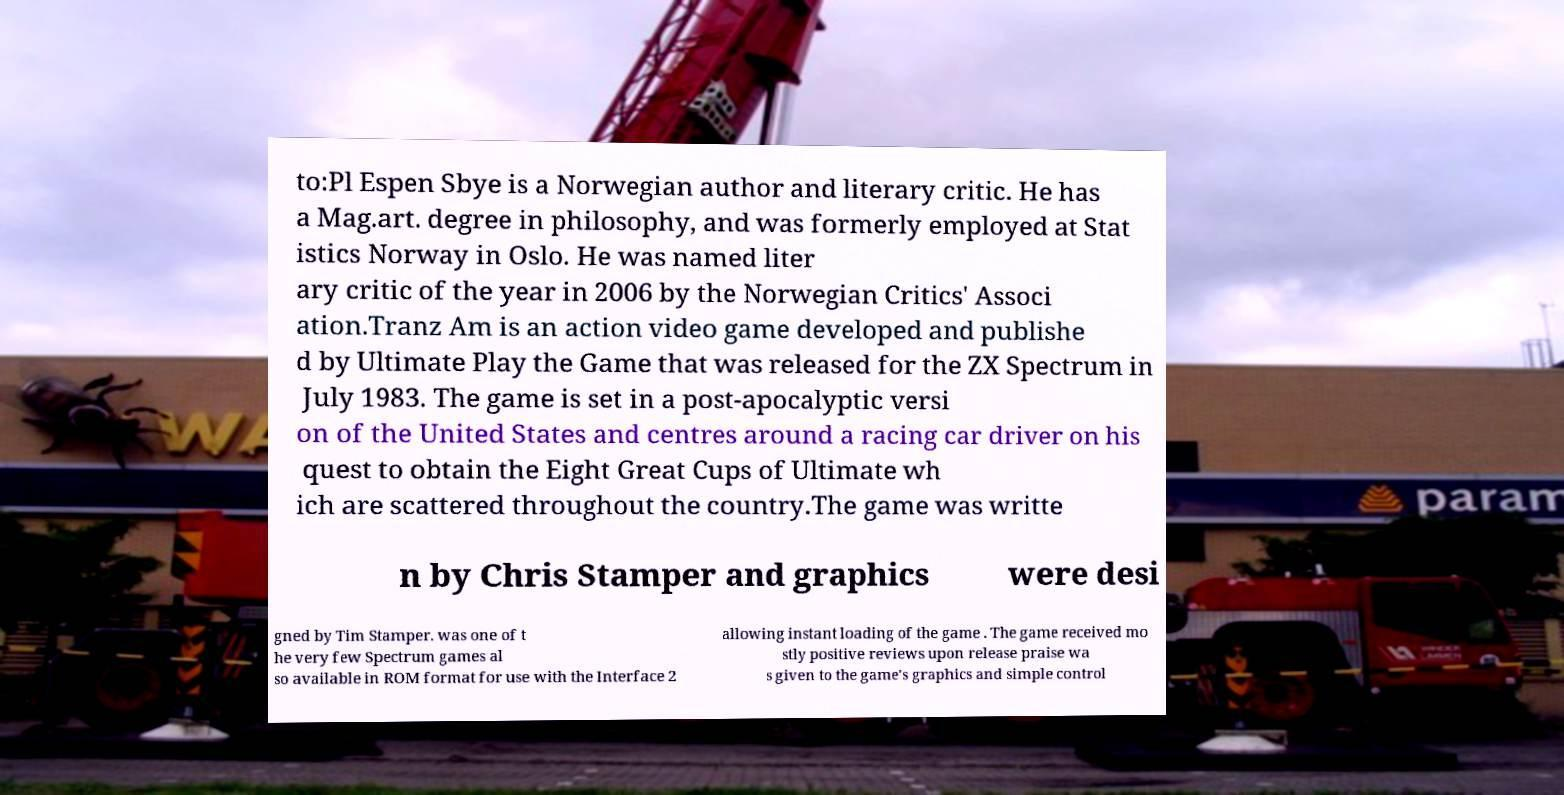Could you extract and type out the text from this image? to:Pl Espen Sbye is a Norwegian author and literary critic. He has a Mag.art. degree in philosophy, and was formerly employed at Stat istics Norway in Oslo. He was named liter ary critic of the year in 2006 by the Norwegian Critics' Associ ation.Tranz Am is an action video game developed and publishe d by Ultimate Play the Game that was released for the ZX Spectrum in July 1983. The game is set in a post-apocalyptic versi on of the United States and centres around a racing car driver on his quest to obtain the Eight Great Cups of Ultimate wh ich are scattered throughout the country.The game was writte n by Chris Stamper and graphics were desi gned by Tim Stamper. was one of t he very few Spectrum games al so available in ROM format for use with the Interface 2 allowing instant loading of the game . The game received mo stly positive reviews upon release praise wa s given to the game's graphics and simple control 